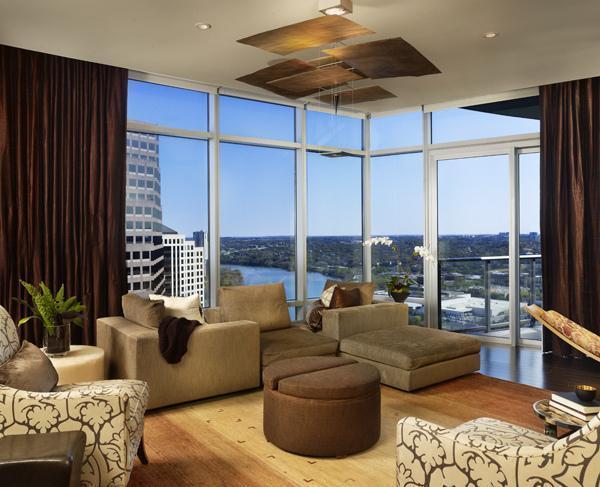How many chairs are in the photo?
Give a very brief answer. 2. How many couches are in the picture?
Give a very brief answer. 5. How many girl are there in the image?
Give a very brief answer. 0. 